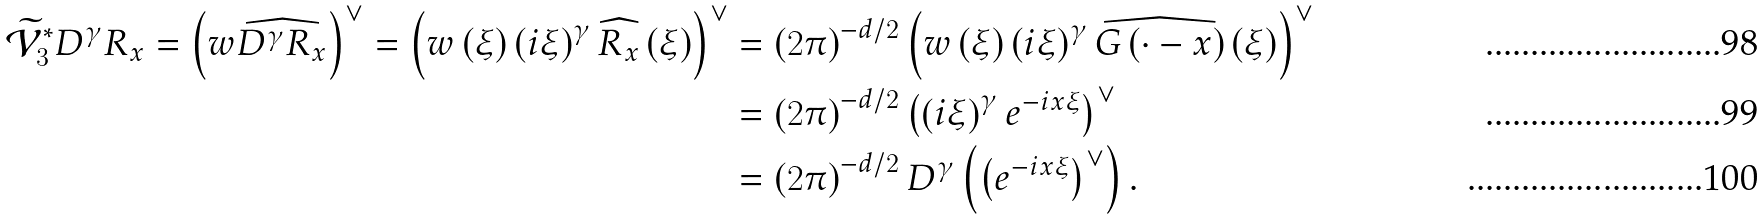Convert formula to latex. <formula><loc_0><loc_0><loc_500><loc_500>\widetilde { \mathcal { V } } _ { 3 } ^ { \ast } D ^ { \gamma } R _ { x } = \left ( w \widehat { D ^ { \gamma } R _ { x } } \right ) ^ { \vee } = \left ( w \left ( \xi \right ) \left ( i \xi \right ) ^ { \gamma } \widehat { R _ { x } } \left ( \xi \right ) \right ) ^ { \vee } & = \left ( 2 \pi \right ) ^ { - d / 2 } \left ( w \left ( \xi \right ) \left ( i \xi \right ) ^ { \gamma } \widehat { G \left ( \cdot - x \right ) } \left ( \xi \right ) \right ) ^ { \vee } \\ & = \left ( 2 \pi \right ) ^ { - d / 2 } \left ( \left ( i \xi \right ) ^ { \gamma } e ^ { - i x \xi } \right ) ^ { \vee } \\ & = \left ( 2 \pi \right ) ^ { - d / 2 } D ^ { \gamma } \left ( \left ( e ^ { - i x \xi } \right ) ^ { \vee } \right ) .</formula> 